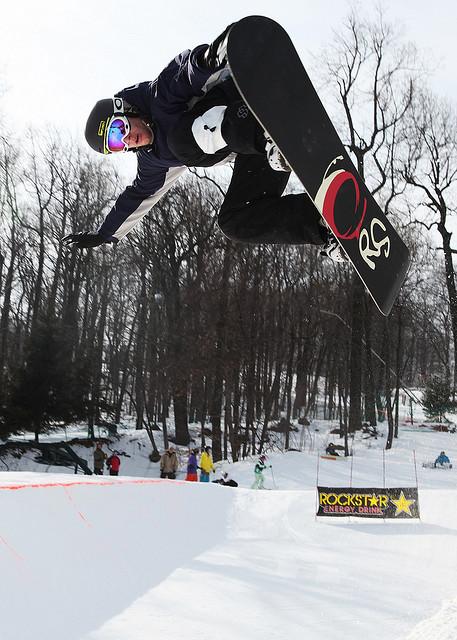Why is the orange line on the surface?
Write a very short answer. Boundary line. What is the person doing?
Concise answer only. Snowboarding. Is there an advertisement for monster energy drinks?
Answer briefly. No. 